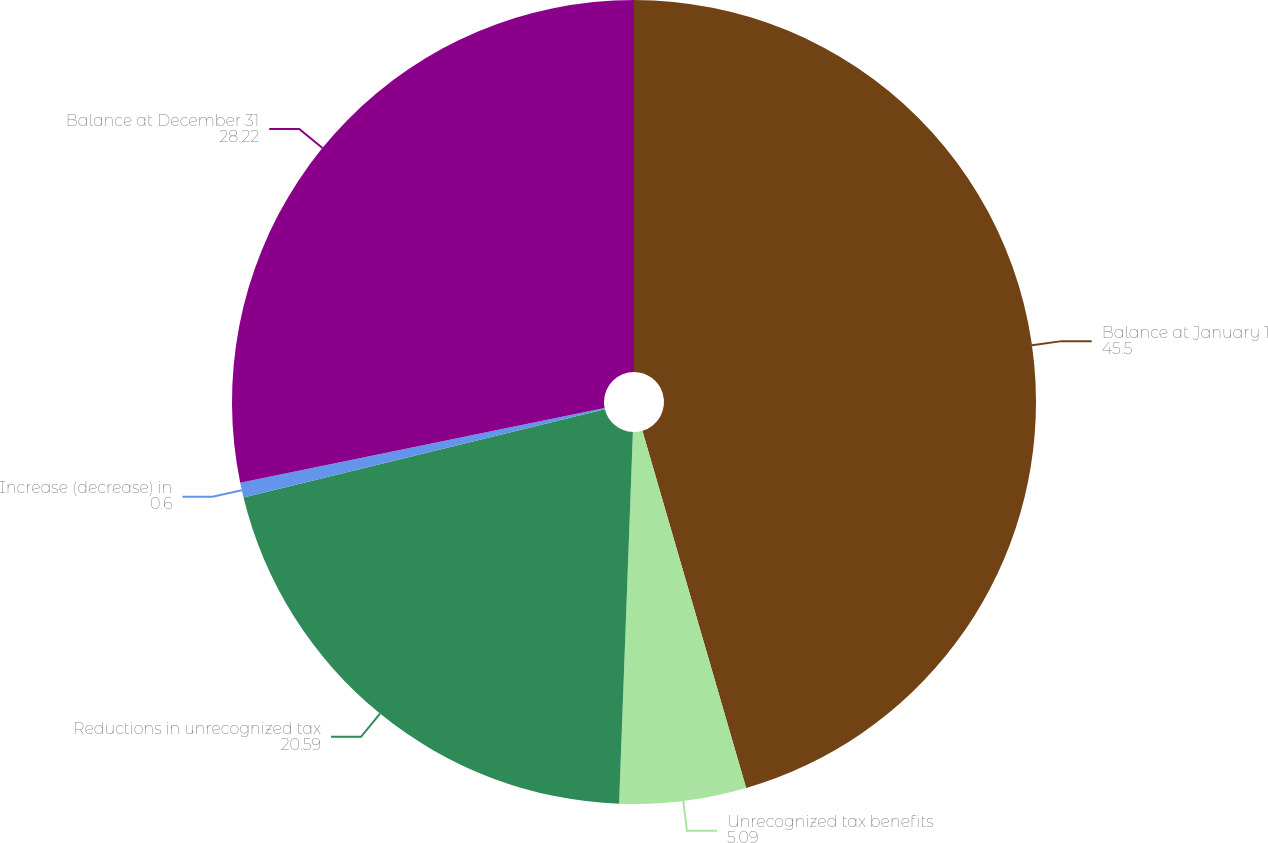Convert chart to OTSL. <chart><loc_0><loc_0><loc_500><loc_500><pie_chart><fcel>Balance at January 1<fcel>Unrecognized tax benefits<fcel>Reductions in unrecognized tax<fcel>Increase (decrease) in<fcel>Balance at December 31<nl><fcel>45.5%<fcel>5.09%<fcel>20.59%<fcel>0.6%<fcel>28.22%<nl></chart> 